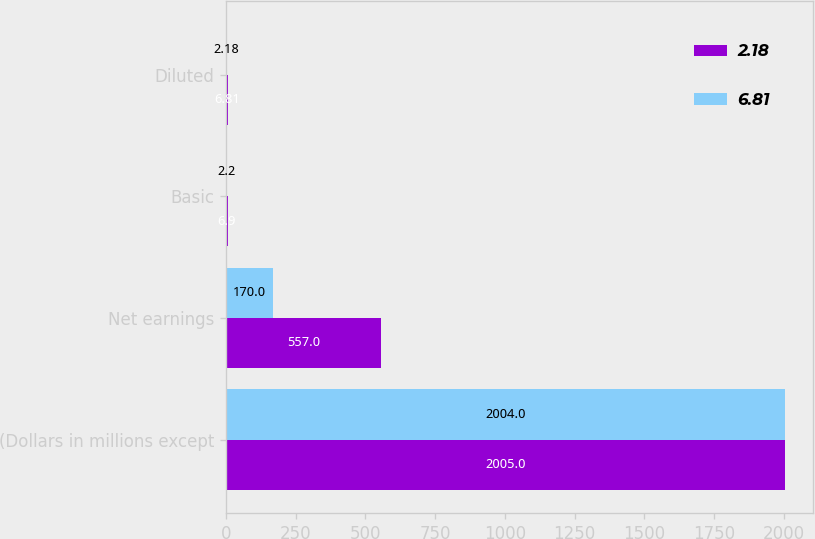Convert chart to OTSL. <chart><loc_0><loc_0><loc_500><loc_500><stacked_bar_chart><ecel><fcel>(Dollars in millions except<fcel>Net earnings<fcel>Basic<fcel>Diluted<nl><fcel>2.18<fcel>2005<fcel>557<fcel>6.9<fcel>6.81<nl><fcel>6.81<fcel>2004<fcel>170<fcel>2.2<fcel>2.18<nl></chart> 